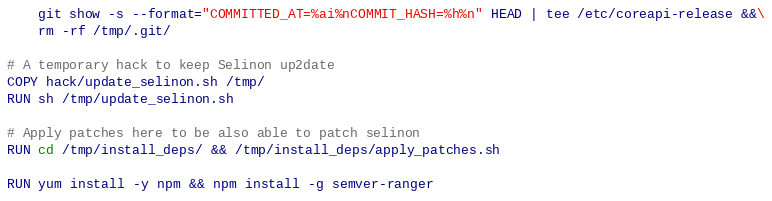Convert code to text. <code><loc_0><loc_0><loc_500><loc_500><_Dockerfile_>    git show -s --format="COMMITTED_AT=%ai%nCOMMIT_HASH=%h%n" HEAD | tee /etc/coreapi-release &&\
    rm -rf /tmp/.git/

# A temporary hack to keep Selinon up2date
COPY hack/update_selinon.sh /tmp/
RUN sh /tmp/update_selinon.sh

# Apply patches here to be also able to patch selinon
RUN cd /tmp/install_deps/ && /tmp/install_deps/apply_patches.sh

RUN yum install -y npm && npm install -g semver-ranger
</code> 